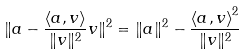<formula> <loc_0><loc_0><loc_500><loc_500>\| a - { \frac { \langle a , v \rangle } { \| v \| ^ { 2 } } } v \| ^ { 2 } = \| a \| ^ { 2 } - { \frac { { \langle a , v \rangle } ^ { 2 } } { \| v \| ^ { 2 } } }</formula> 